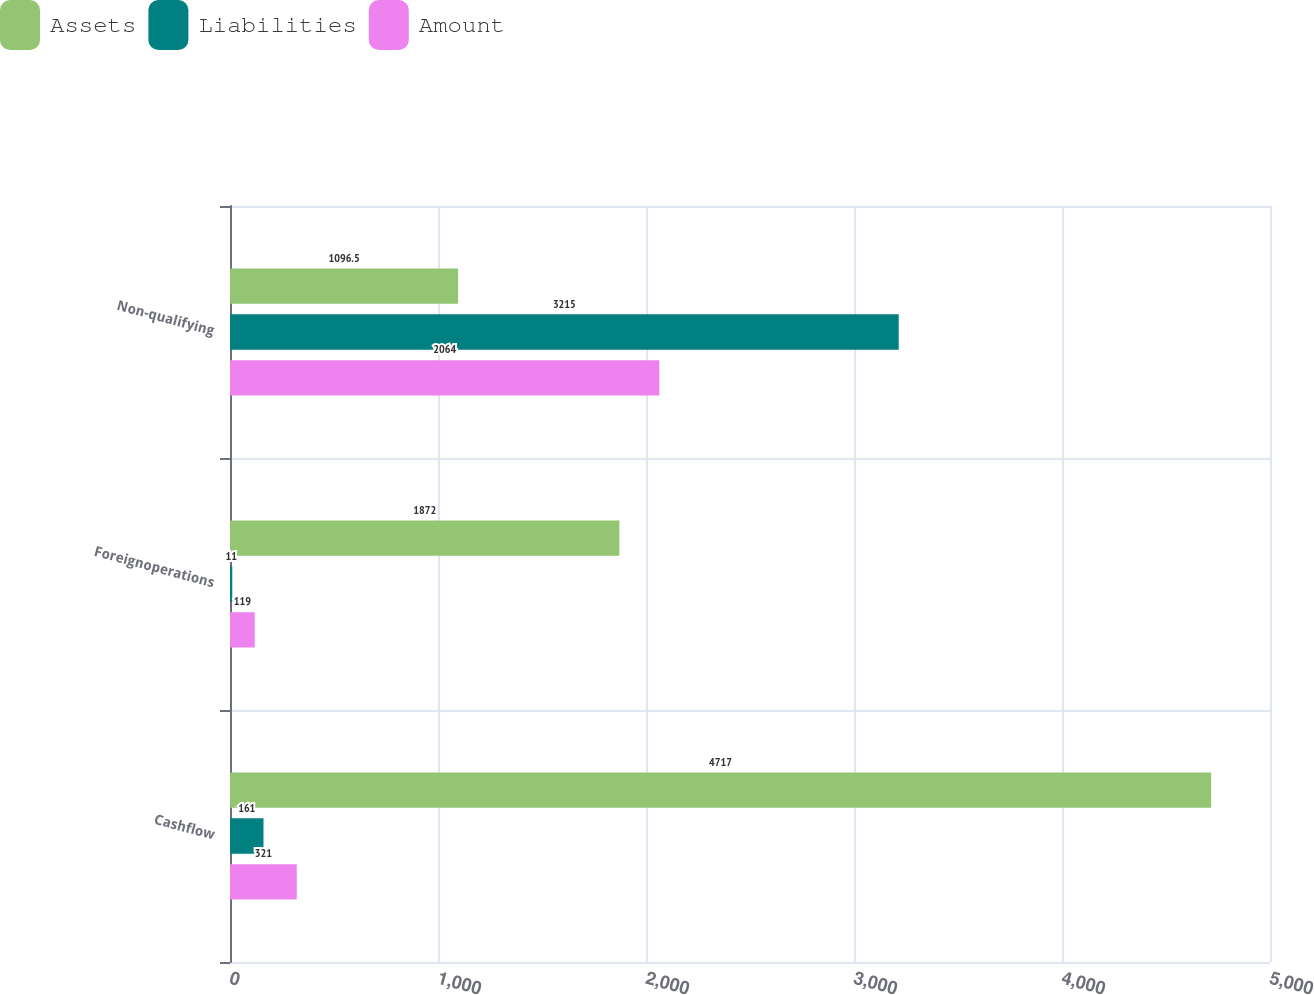<chart> <loc_0><loc_0><loc_500><loc_500><stacked_bar_chart><ecel><fcel>Cashflow<fcel>Foreignoperations<fcel>Non-qualifying<nl><fcel>Assets<fcel>4717<fcel>1872<fcel>1096.5<nl><fcel>Liabilities<fcel>161<fcel>11<fcel>3215<nl><fcel>Amount<fcel>321<fcel>119<fcel>2064<nl></chart> 